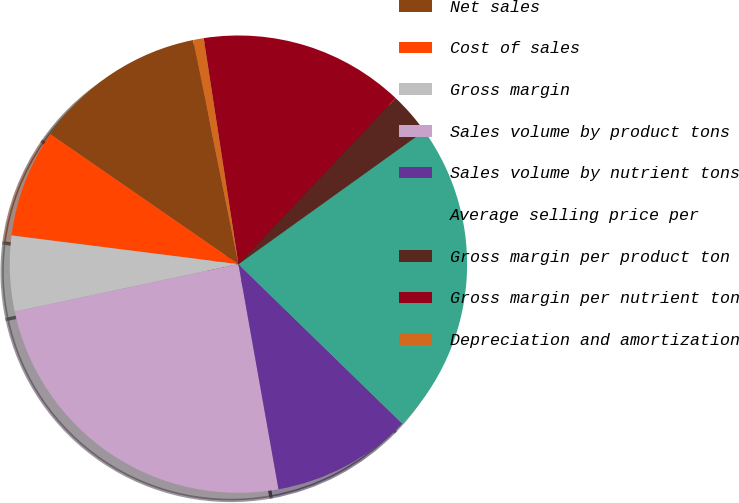Convert chart. <chart><loc_0><loc_0><loc_500><loc_500><pie_chart><fcel>Net sales<fcel>Cost of sales<fcel>Gross margin<fcel>Sales volume by product tons<fcel>Sales volume by nutrient tons<fcel>Average selling price per<fcel>Gross margin per product ton<fcel>Gross margin per nutrient ton<fcel>Depreciation and amortization<nl><fcel>12.2%<fcel>7.62%<fcel>5.33%<fcel>24.48%<fcel>9.91%<fcel>22.19%<fcel>3.04%<fcel>14.49%<fcel>0.75%<nl></chart> 